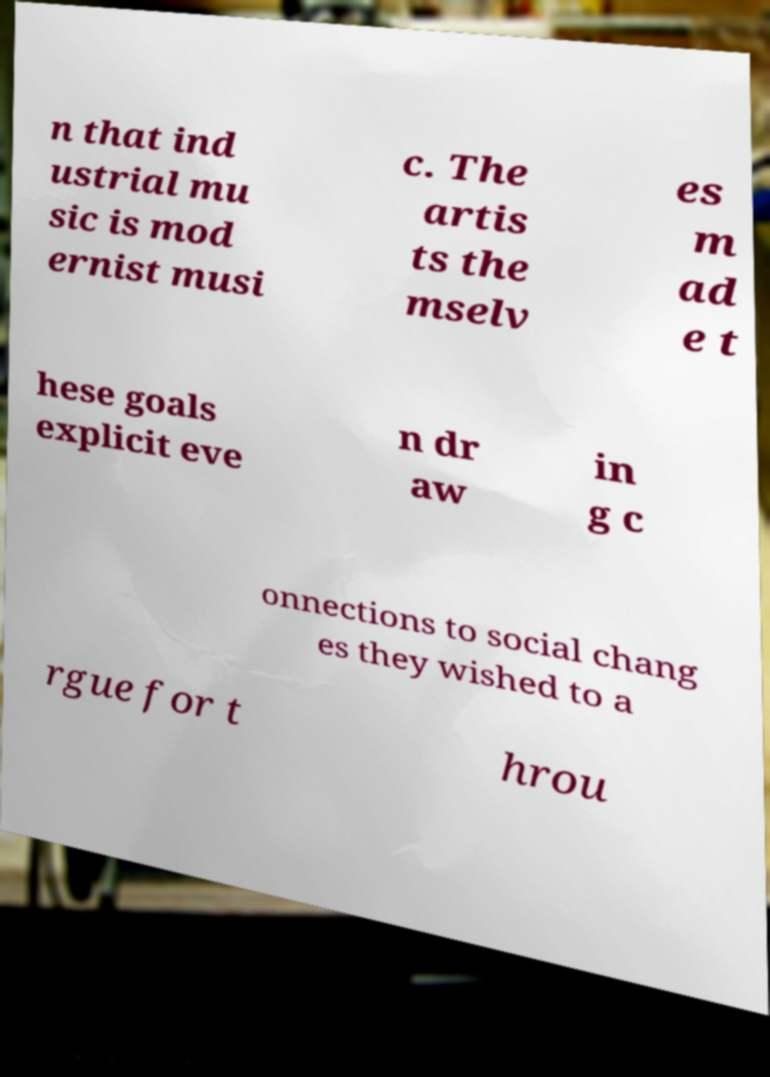Please identify and transcribe the text found in this image. n that ind ustrial mu sic is mod ernist musi c. The artis ts the mselv es m ad e t hese goals explicit eve n dr aw in g c onnections to social chang es they wished to a rgue for t hrou 